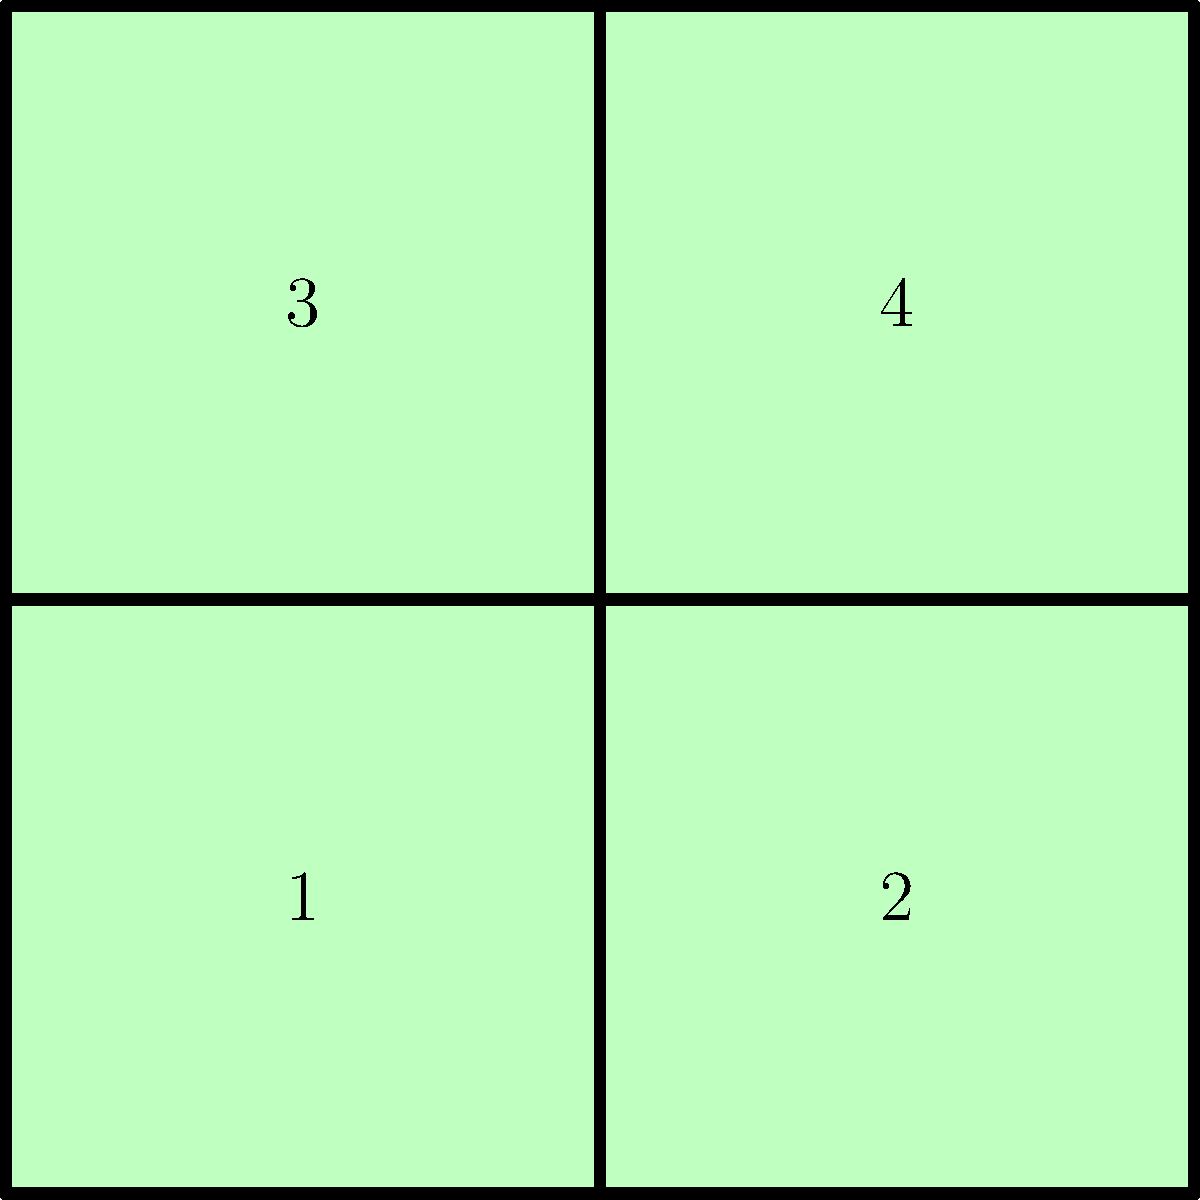Look at the jigsaw puzzle pieces shown above. How many pieces do you need to connect to complete the square puzzle? Let's approach this step-by-step:

1. First, we need to count the total number of pieces shown in the image. We can see that there are 4 large, square-shaped pieces labeled 1, 2, 3, and 4.

2. Next, we need to understand what it means to "complete" the puzzle. A completed puzzle would form a larger square without any gaps.

3. Now, let's look at how these pieces fit together:
   - Piece 1 connects to Piece 2 on the right side
   - Piece 1 connects to Piece 3 on the top side
   - Piece 2 connects to Piece 4 on the top side
   - Piece 3 connects to Piece 4 on the right side

4. To complete the puzzle, we need to connect all of these pieces together. This means we need to use all 4 pieces.

5. Therefore, the number of pieces needed to complete the square puzzle is 4.
Answer: 4 pieces 